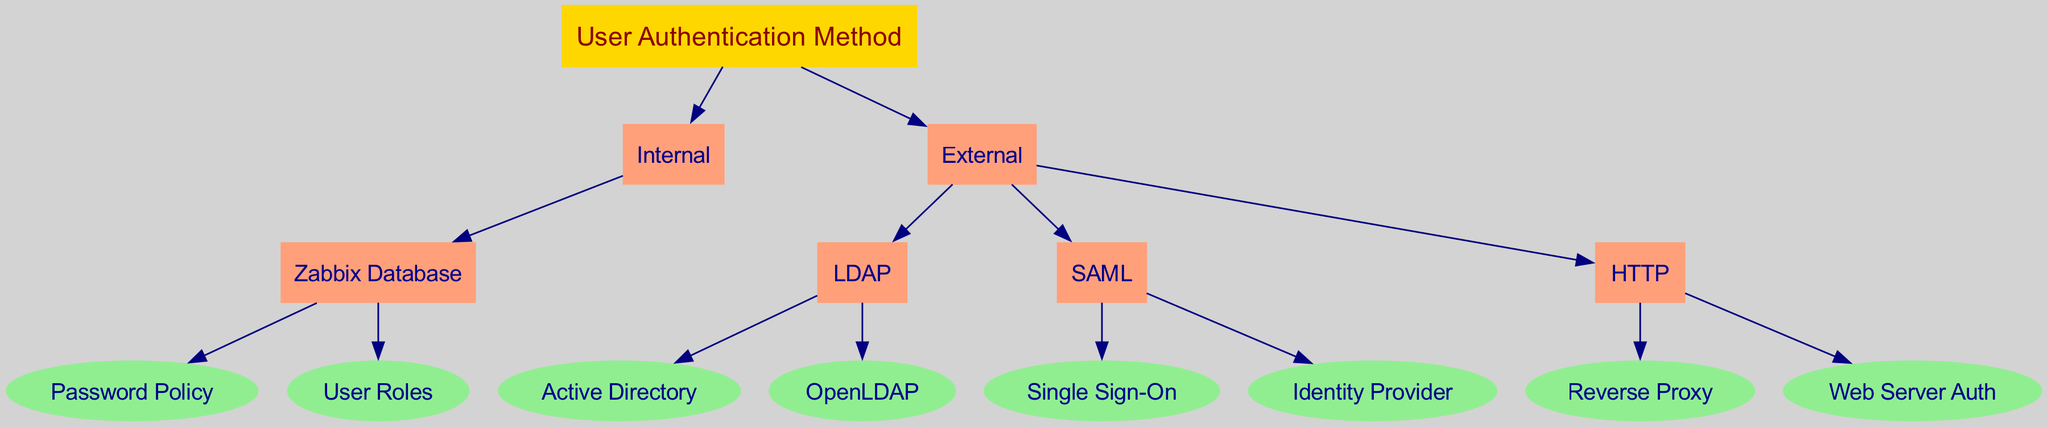What is the root node of the decision tree? The root node represents the main topic of the decision tree, which in this case is "User Authentication Method."
Answer: User Authentication Method How many external methods are available for user authentication? By counting the children nodes under the "External" node, there are three methods: "LDAP," "SAML," and "HTTP."
Answer: 3 What is the child node of "Internal"? Looking at the "Internal" node, it has one child node, which is "Zabbix Database."
Answer: Zabbix Database Which node represents "Active Directory"? "Active Directory" is a child node under the "LDAP" parent node in the "External" user authentication method section.
Answer: Active Directory How many child nodes does the "SAML" method have? The "SAML" node has two child nodes: "Single Sign-On" and "Identity Provider."
Answer: 2 What is the relationship between "HTTP" and "Reverse Proxy"? "Reverse Proxy" is a child node of the "HTTP" authentication method, indicating that it is a specific type of external user authentication method.
Answer: child Which method is represented as an internal authentication option? The internal authentication option represented in the diagram is "Zabbix Database," under the "Internal" node.
Answer: Zabbix Database What does the "Password Policy" node represent? The "Password Policy" node indicates a specific aspect of user authentication related to internal authentication in the Zabbix Database.
Answer: Password Policy Name two child nodes of the "External" authentication methods. The child nodes under "External" include "LDAP" and "SAML," among others, making these two a valid answer.
Answer: LDAP, SAML What type of node is "Identity Provider"? "Identity Provider" is a child node of the "SAML" method and is classified as an endpoint node since it does not have further children.
Answer: endpoint 